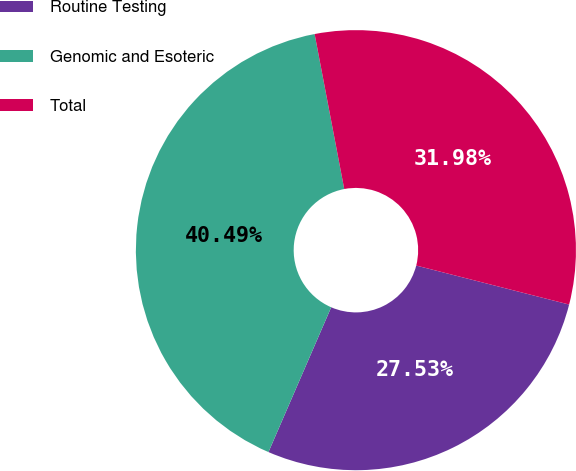Convert chart. <chart><loc_0><loc_0><loc_500><loc_500><pie_chart><fcel>Routine Testing<fcel>Genomic and Esoteric<fcel>Total<nl><fcel>27.53%<fcel>40.49%<fcel>31.98%<nl></chart> 